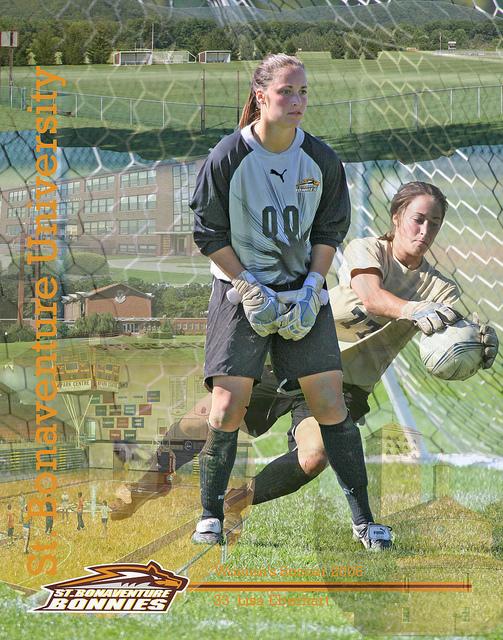What level of play is being advertised?
Concise answer only. College. What sport is this?
Be succinct. Soccer. What game is being played?
Write a very short answer. Soccer. 